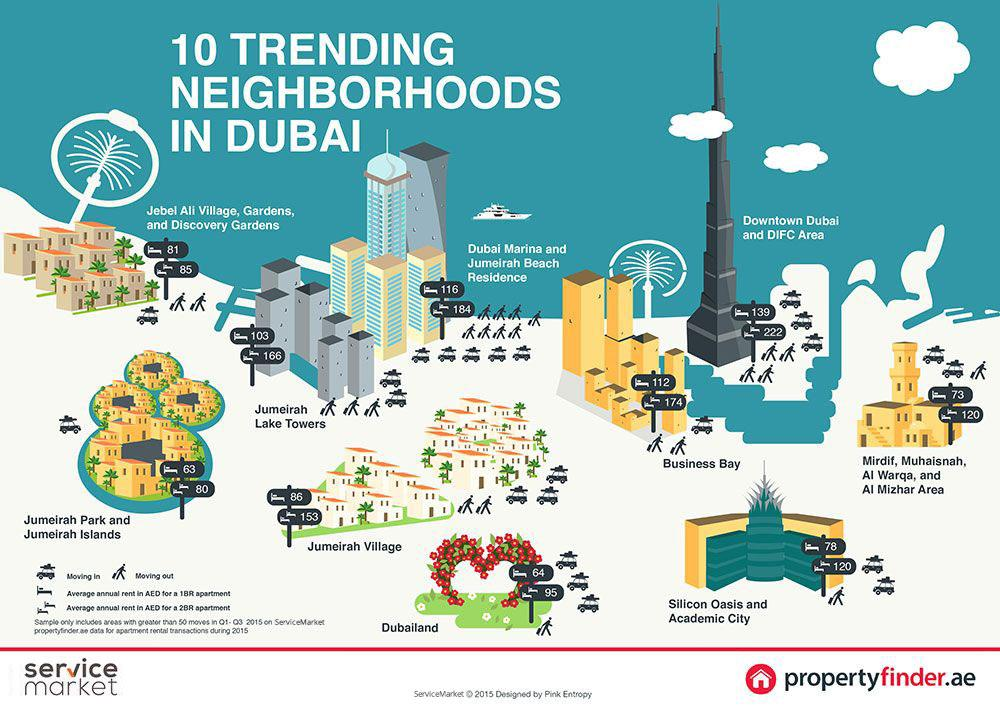Draw attention to some important aspects in this diagram. According to the provided graphic, the neighborhood with the highest annual rent rates is Downtown Dubai and DIFC Area. In Business Bay, it is possible to find a 2-bedroom apartment with an average annual rent of 174 AED. It is possible to find a 1 bedroom apartment in a neighborhood with an average annual rent of 78 AED in Silicon Oasis and Academic City. The highest average rent for a 1-bedroom apartment shown in the infographic is 139 dollars. The average annual rent in AED for a 1BR apartment in Jumeirah Lake Towers is 103. 